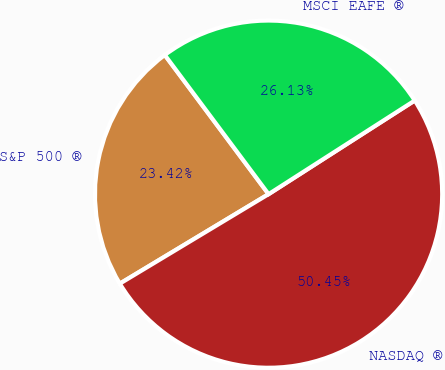<chart> <loc_0><loc_0><loc_500><loc_500><pie_chart><fcel>S&P 500 ®<fcel>NASDAQ ®<fcel>MSCI EAFE ®<nl><fcel>23.42%<fcel>50.45%<fcel>26.13%<nl></chart> 